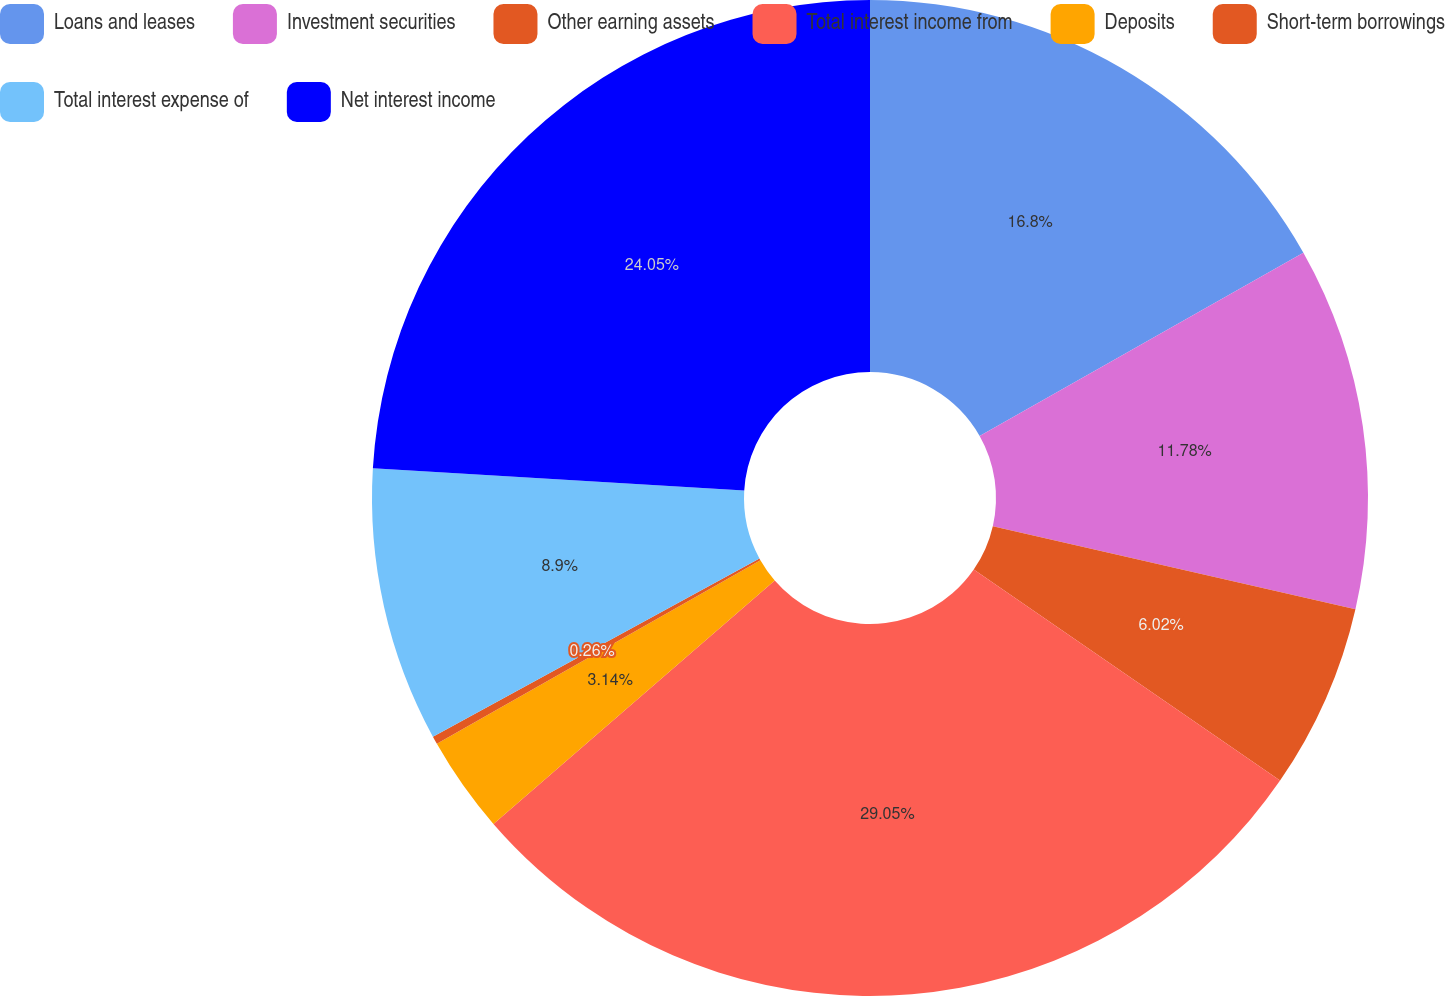<chart> <loc_0><loc_0><loc_500><loc_500><pie_chart><fcel>Loans and leases<fcel>Investment securities<fcel>Other earning assets<fcel>Total interest income from<fcel>Deposits<fcel>Short-term borrowings<fcel>Total interest expense of<fcel>Net interest income<nl><fcel>16.8%<fcel>11.78%<fcel>6.02%<fcel>29.04%<fcel>3.14%<fcel>0.26%<fcel>8.9%<fcel>24.05%<nl></chart> 